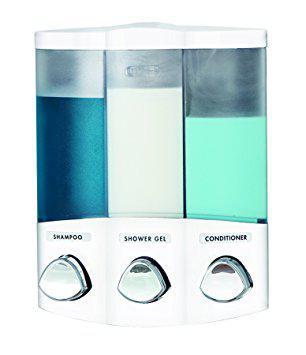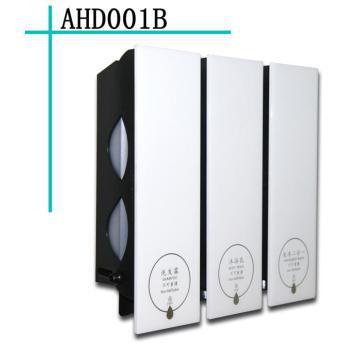The first image is the image on the left, the second image is the image on the right. Evaluate the accuracy of this statement regarding the images: "The right image contains a soap dispenser and the soap container the furthest to the right is bright green.". Is it true? Answer yes or no. No. 